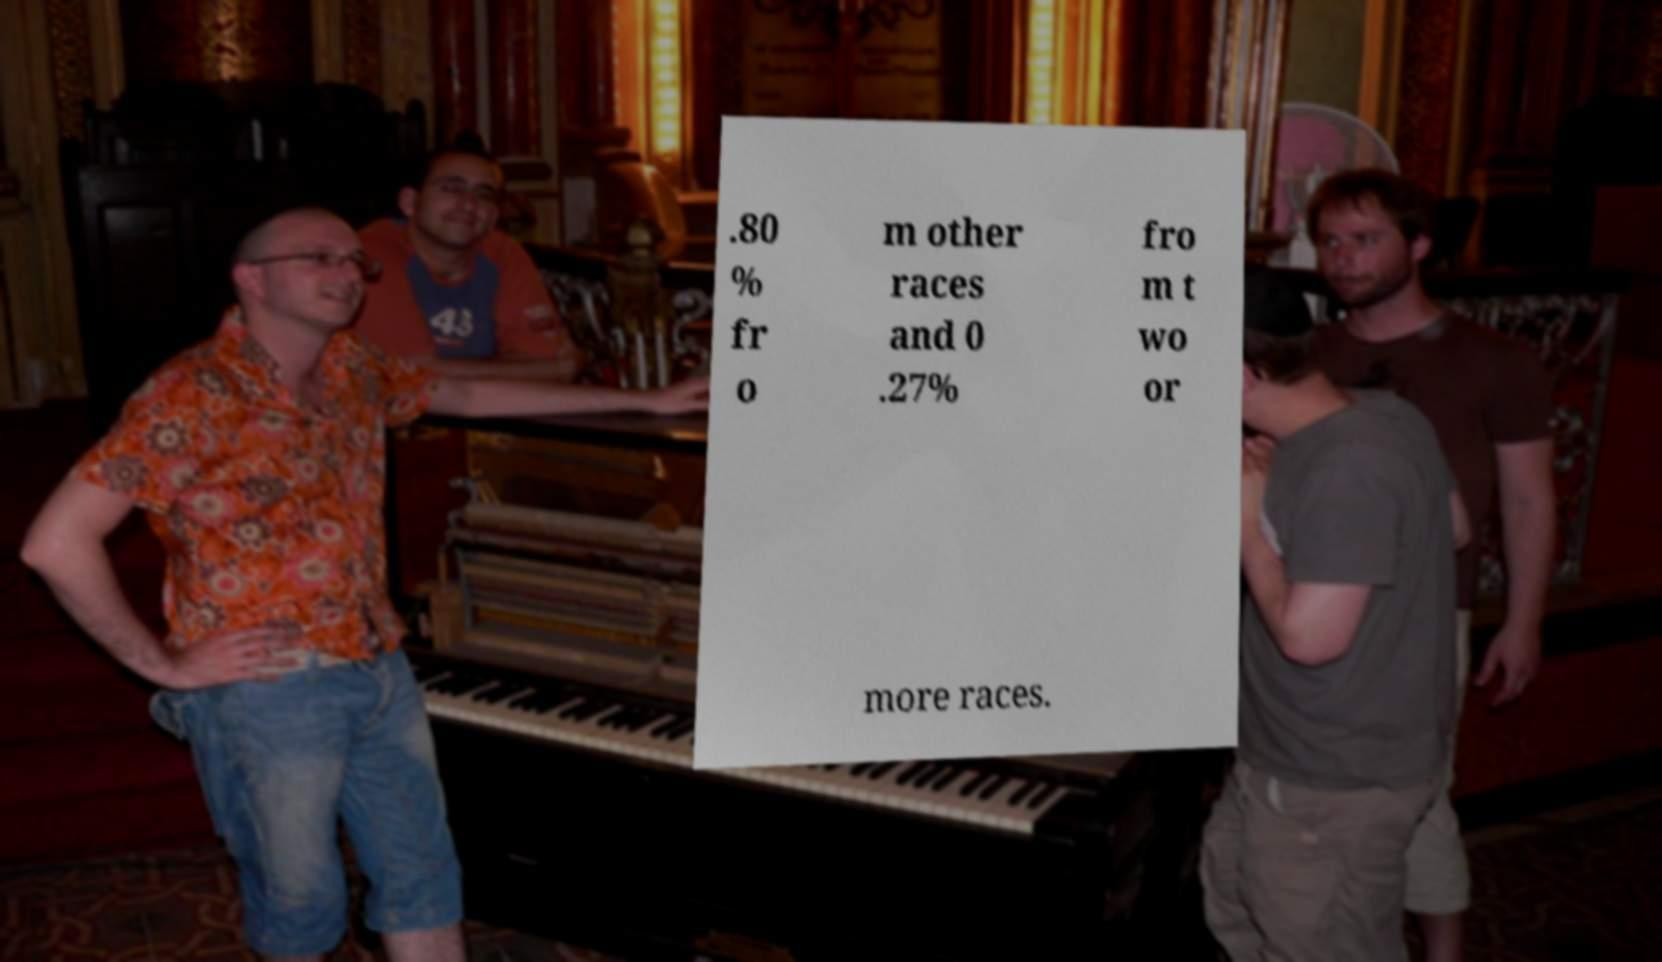There's text embedded in this image that I need extracted. Can you transcribe it verbatim? .80 % fr o m other races and 0 .27% fro m t wo or more races. 